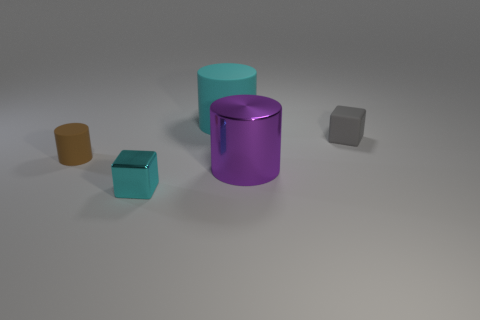How many other objects are the same shape as the cyan rubber object?
Ensure brevity in your answer.  2. There is a cyan thing that is behind the tiny rubber thing behind the small matte thing in front of the small matte cube; how big is it?
Ensure brevity in your answer.  Large. How many green objects are either small rubber cylinders or big matte objects?
Provide a short and direct response. 0. The tiny rubber thing on the left side of the cylinder behind the tiny brown rubber cylinder is what shape?
Keep it short and to the point. Cylinder. There is a cube that is on the left side of the cyan cylinder; does it have the same size as the cyan object to the right of the tiny cyan thing?
Offer a terse response. No. Is there a large purple thing made of the same material as the purple cylinder?
Provide a succinct answer. No. What size is the rubber cylinder that is the same color as the metal block?
Give a very brief answer. Large. There is a big cyan cylinder that is behind the small block that is left of the rubber block; is there a small cylinder that is right of it?
Give a very brief answer. No. There is a tiny rubber cylinder; are there any small cylinders on the left side of it?
Offer a very short reply. No. There is a tiny cube that is on the right side of the large purple metallic cylinder; how many cylinders are behind it?
Offer a terse response. 1. 